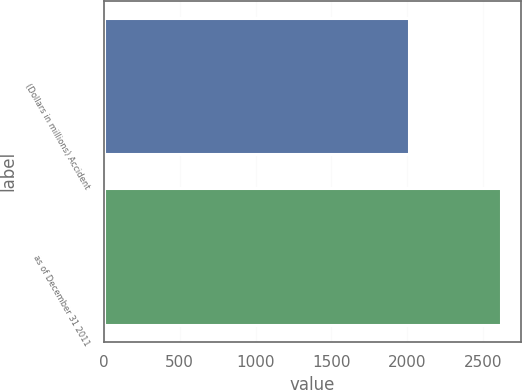<chart> <loc_0><loc_0><loc_500><loc_500><bar_chart><fcel>(Dollars in millions) Accident<fcel>as of December 31 2011<nl><fcel>2011<fcel>2620<nl></chart> 